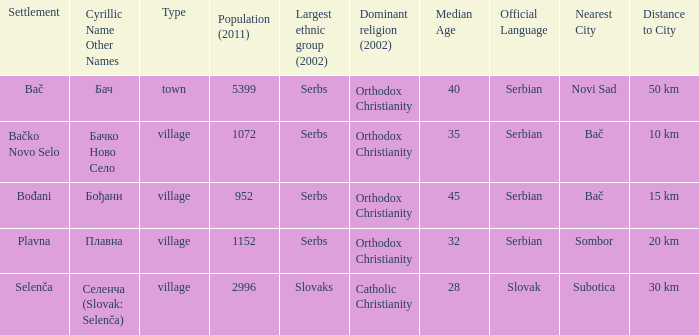What is the smallest population listed? 952.0. 